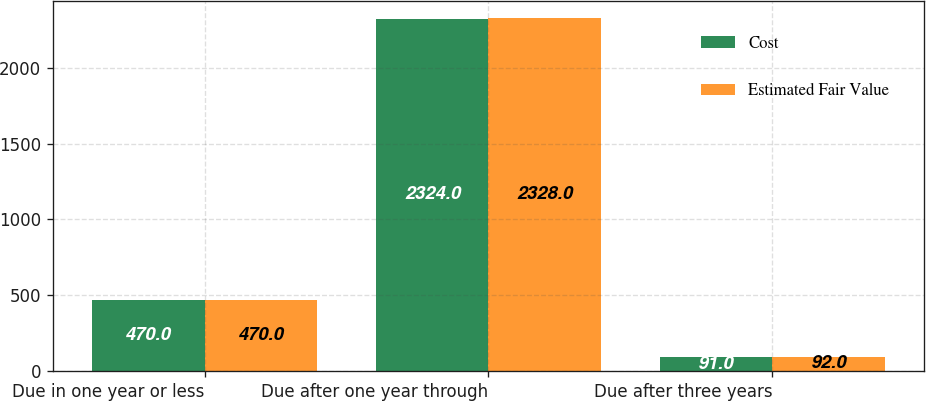<chart> <loc_0><loc_0><loc_500><loc_500><stacked_bar_chart><ecel><fcel>Due in one year or less<fcel>Due after one year through<fcel>Due after three years<nl><fcel>Cost<fcel>470<fcel>2324<fcel>91<nl><fcel>Estimated Fair Value<fcel>470<fcel>2328<fcel>92<nl></chart> 